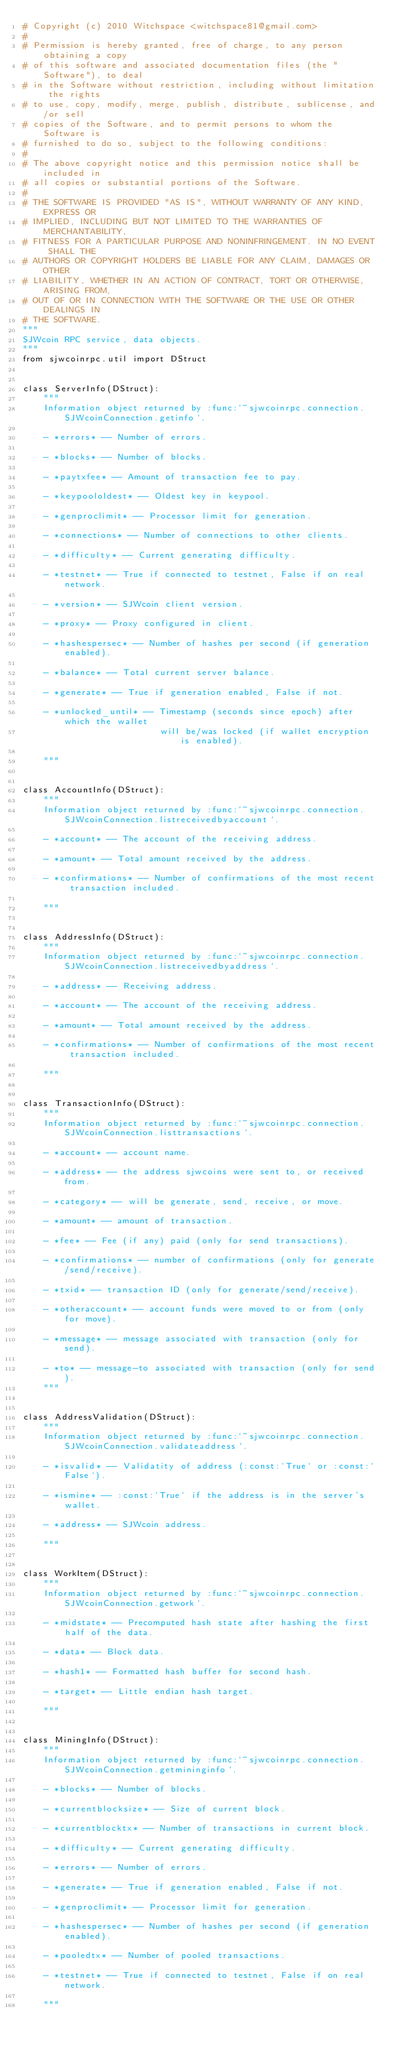<code> <loc_0><loc_0><loc_500><loc_500><_Python_># Copyright (c) 2010 Witchspace <witchspace81@gmail.com>
#
# Permission is hereby granted, free of charge, to any person obtaining a copy
# of this software and associated documentation files (the "Software"), to deal
# in the Software without restriction, including without limitation the rights
# to use, copy, modify, merge, publish, distribute, sublicense, and/or sell
# copies of the Software, and to permit persons to whom the Software is
# furnished to do so, subject to the following conditions:
#
# The above copyright notice and this permission notice shall be included in
# all copies or substantial portions of the Software.
#
# THE SOFTWARE IS PROVIDED "AS IS", WITHOUT WARRANTY OF ANY KIND, EXPRESS OR
# IMPLIED, INCLUDING BUT NOT LIMITED TO THE WARRANTIES OF MERCHANTABILITY,
# FITNESS FOR A PARTICULAR PURPOSE AND NONINFRINGEMENT. IN NO EVENT SHALL THE
# AUTHORS OR COPYRIGHT HOLDERS BE LIABLE FOR ANY CLAIM, DAMAGES OR OTHER
# LIABILITY, WHETHER IN AN ACTION OF CONTRACT, TORT OR OTHERWISE, ARISING FROM,
# OUT OF OR IN CONNECTION WITH THE SOFTWARE OR THE USE OR OTHER DEALINGS IN
# THE SOFTWARE.
"""
SJWcoin RPC service, data objects.
"""
from sjwcoinrpc.util import DStruct


class ServerInfo(DStruct):
    """
    Information object returned by :func:`~sjwcoinrpc.connection.SJWcoinConnection.getinfo`.

    - *errors* -- Number of errors.

    - *blocks* -- Number of blocks.

    - *paytxfee* -- Amount of transaction fee to pay.

    - *keypoololdest* -- Oldest key in keypool.

    - *genproclimit* -- Processor limit for generation.

    - *connections* -- Number of connections to other clients.

    - *difficulty* -- Current generating difficulty.

    - *testnet* -- True if connected to testnet, False if on real network.

    - *version* -- SJWcoin client version.

    - *proxy* -- Proxy configured in client.

    - *hashespersec* -- Number of hashes per second (if generation enabled).

    - *balance* -- Total current server balance.

    - *generate* -- True if generation enabled, False if not.

    - *unlocked_until* -- Timestamp (seconds since epoch) after which the wallet
                          will be/was locked (if wallet encryption is enabled).

    """


class AccountInfo(DStruct):
    """
    Information object returned by :func:`~sjwcoinrpc.connection.SJWcoinConnection.listreceivedbyaccount`.

    - *account* -- The account of the receiving address.

    - *amount* -- Total amount received by the address.

    - *confirmations* -- Number of confirmations of the most recent transaction included.

    """


class AddressInfo(DStruct):
    """
    Information object returned by :func:`~sjwcoinrpc.connection.SJWcoinConnection.listreceivedbyaddress`.

    - *address* -- Receiving address.

    - *account* -- The account of the receiving address.

    - *amount* -- Total amount received by the address.

    - *confirmations* -- Number of confirmations of the most recent transaction included.

    """


class TransactionInfo(DStruct):
    """
    Information object returned by :func:`~sjwcoinrpc.connection.SJWcoinConnection.listtransactions`.

    - *account* -- account name.

    - *address* -- the address sjwcoins were sent to, or received from.
    
    - *category* -- will be generate, send, receive, or move.

    - *amount* -- amount of transaction.

    - *fee* -- Fee (if any) paid (only for send transactions).

    - *confirmations* -- number of confirmations (only for generate/send/receive).

    - *txid* -- transaction ID (only for generate/send/receive).

    - *otheraccount* -- account funds were moved to or from (only for move).

    - *message* -- message associated with transaction (only for send).

    - *to* -- message-to associated with transaction (only for send).
    """


class AddressValidation(DStruct):
    """
    Information object returned by :func:`~sjwcoinrpc.connection.SJWcoinConnection.validateaddress`.

    - *isvalid* -- Validatity of address (:const:`True` or :const:`False`).

    - *ismine* -- :const:`True` if the address is in the server's wallet.

    - *address* -- SJWcoin address.

    """


class WorkItem(DStruct):
    """
    Information object returned by :func:`~sjwcoinrpc.connection.SJWcoinConnection.getwork`.

    - *midstate* -- Precomputed hash state after hashing the first half of the data.

    - *data* -- Block data.

    - *hash1* -- Formatted hash buffer for second hash.

    - *target* -- Little endian hash target.

    """


class MiningInfo(DStruct):
    """
    Information object returned by :func:`~sjwcoinrpc.connection.SJWcoinConnection.getmininginfo`.

    - *blocks* -- Number of blocks.

    - *currentblocksize* -- Size of current block.

    - *currentblocktx* -- Number of transactions in current block.

    - *difficulty* -- Current generating difficulty.

    - *errors* -- Number of errors.

    - *generate* -- True if generation enabled, False if not.

    - *genproclimit* -- Processor limit for generation.

    - *hashespersec* -- Number of hashes per second (if generation enabled).

    - *pooledtx* -- Number of pooled transactions.

    - *testnet* -- True if connected to testnet, False if on real network.

    """
</code> 